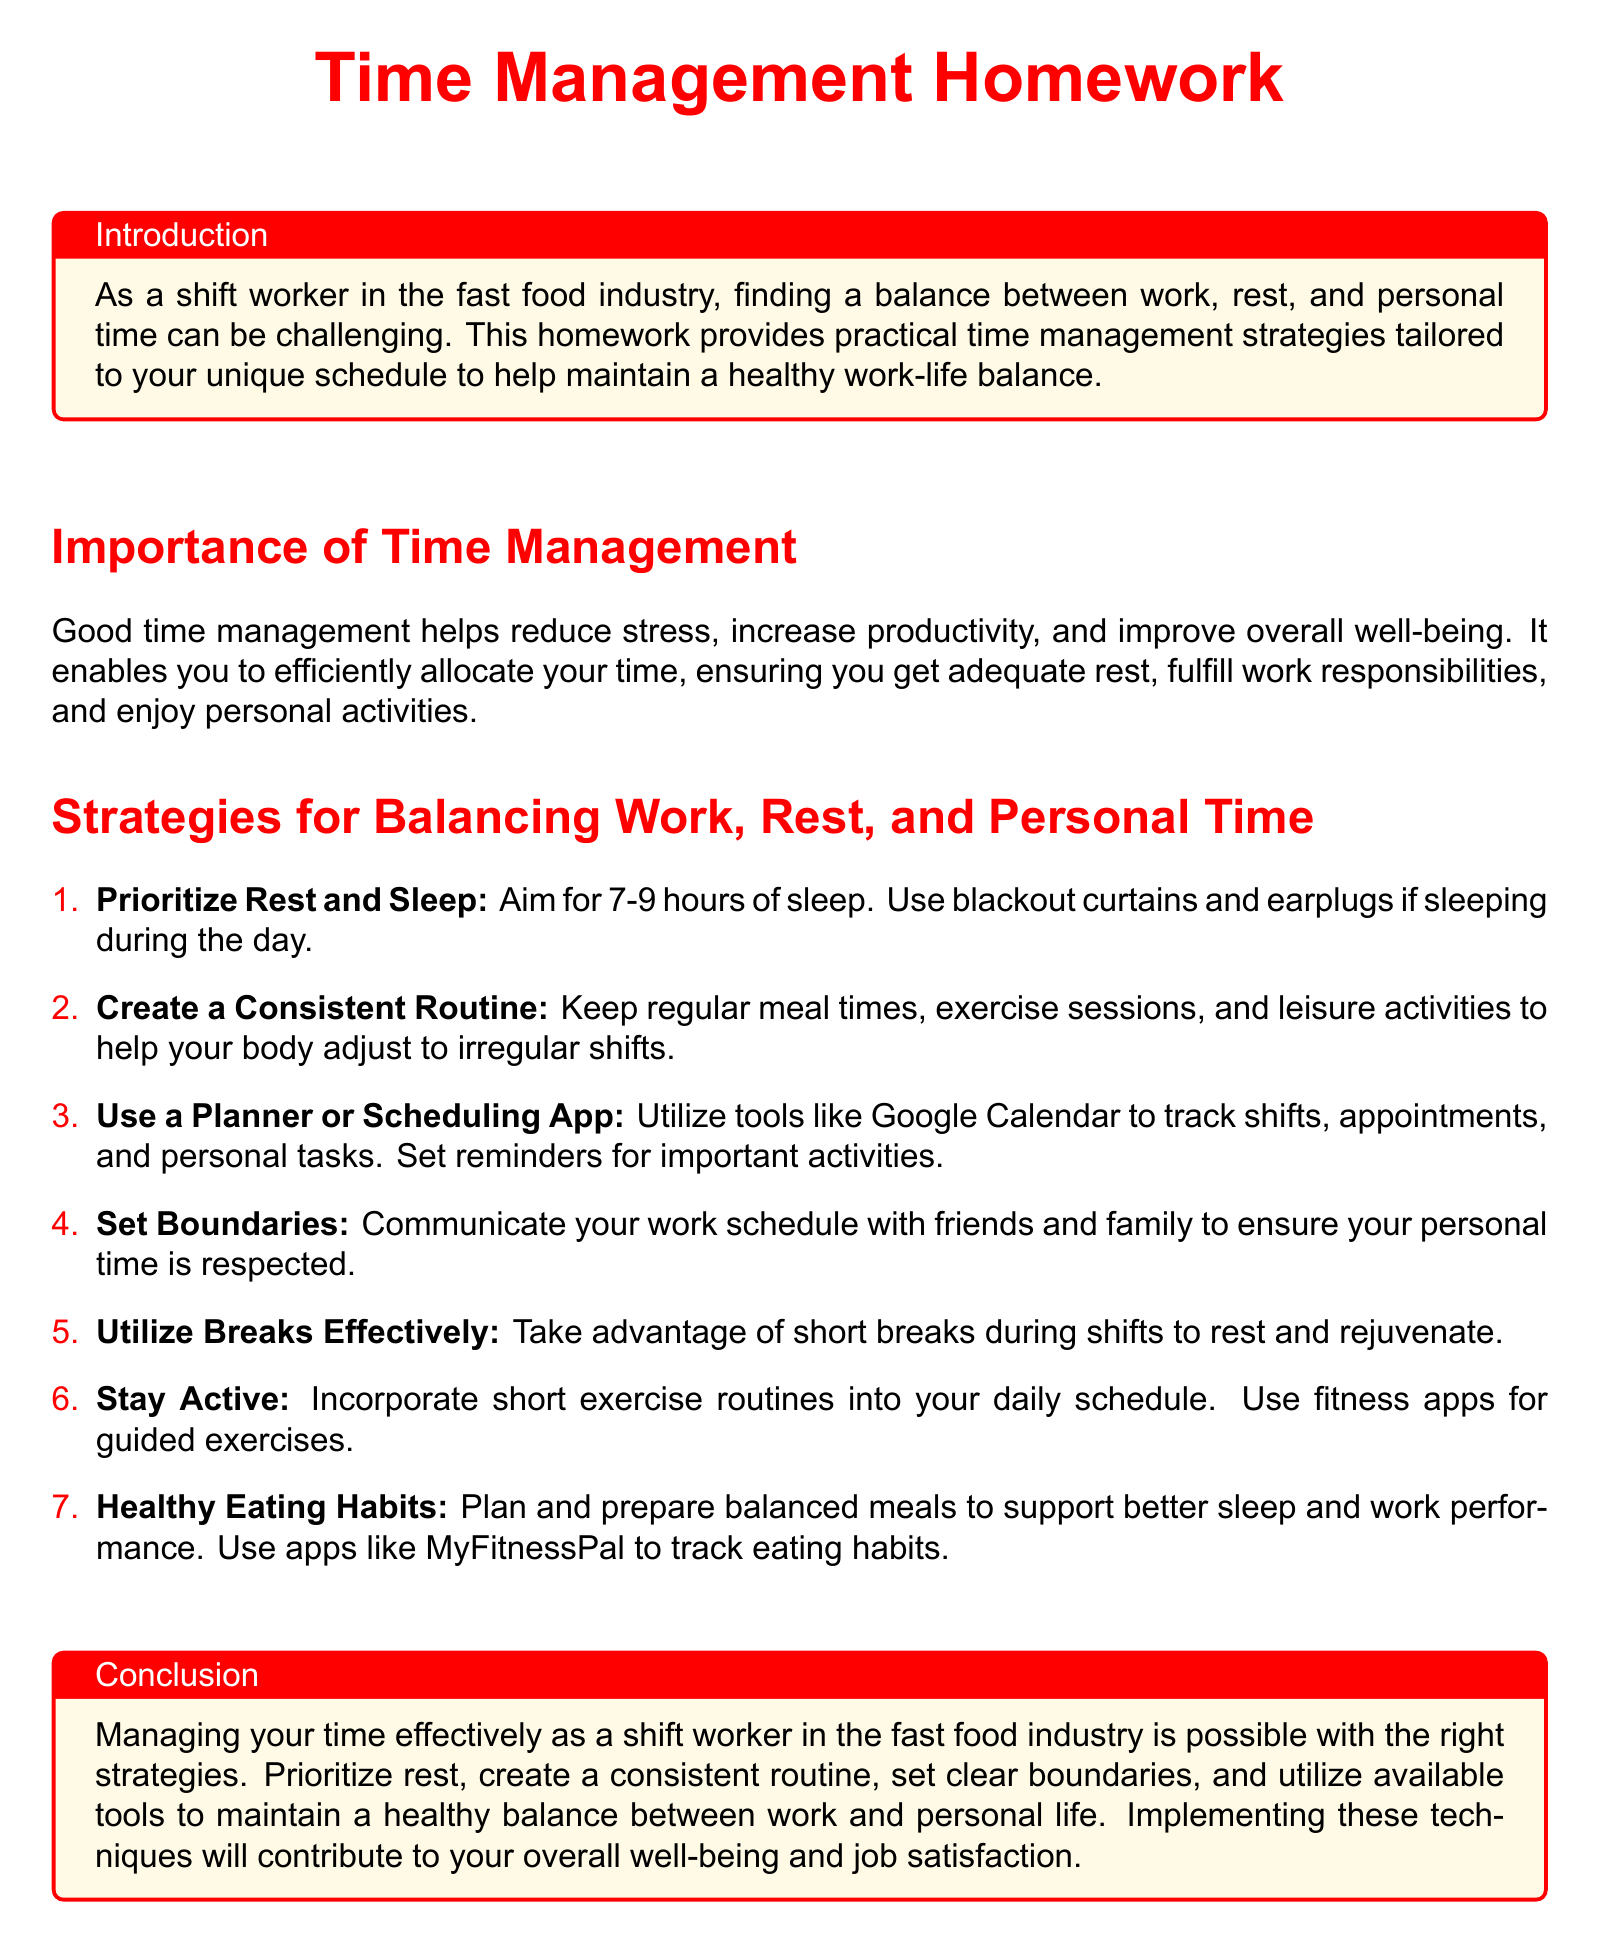What is the title of the homework? The title of the homework is highlighted at the beginning of the document.
Answer: Time Management Homework How many hours of sleep should shift workers aim for? The document specifies a recommended range for sleep duration.
Answer: 7-9 hours What is suggested to help improve sleep when working day shifts? The document lists specific suggestions for improving sleep quality.
Answer: Blackout curtains and earplugs What tool is recommended for tracking shifts and personal tasks? The document mentions a specific type of tool for organization.
Answer: Google Calendar What is one way to utilize short breaks during shifts? The document provides a suggestion for using breaks effectively.
Answer: Rest and rejuvenate Why is creating a consistent routine important for shift workers? The document explains the benefits of routine for shift workers.
Answer: Helps body adjust to irregular shifts What kind of app can be used for tracking eating habits? The document names a specific app to aid in monitoring food intake.
Answer: MyFitnessPal What strategy involves communicating your work schedule? The document refers to a specific method to maintain personal time.
Answer: Set boundaries 